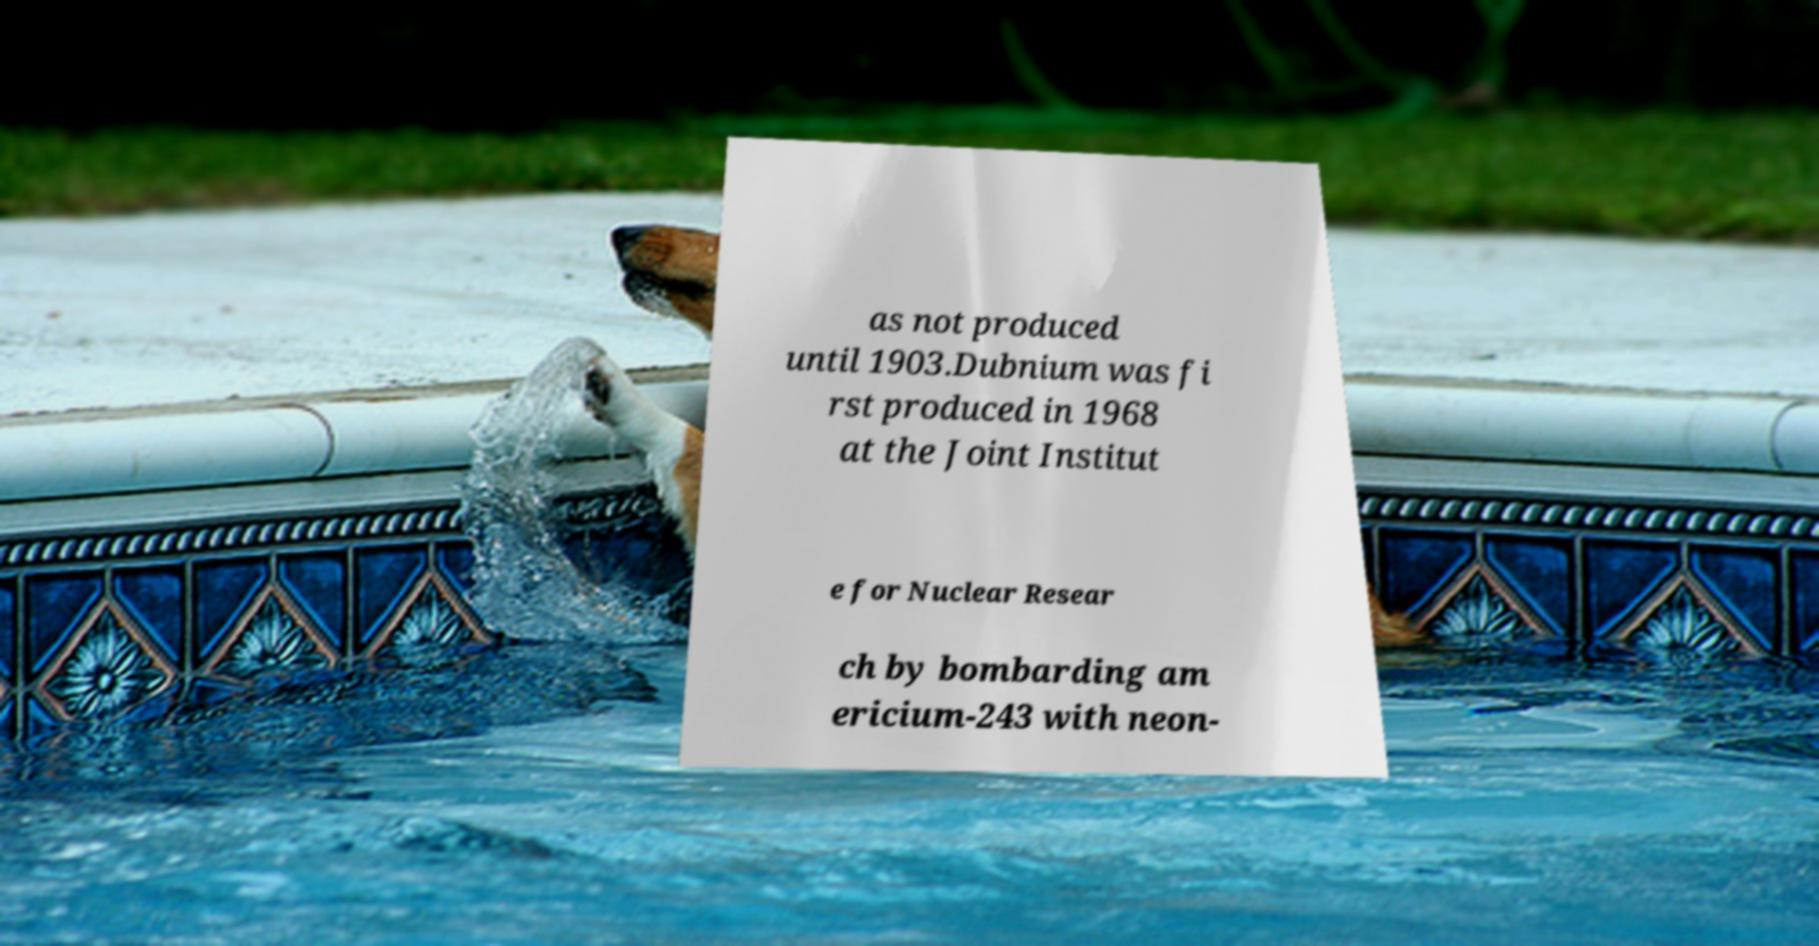Could you assist in decoding the text presented in this image and type it out clearly? as not produced until 1903.Dubnium was fi rst produced in 1968 at the Joint Institut e for Nuclear Resear ch by bombarding am ericium-243 with neon- 